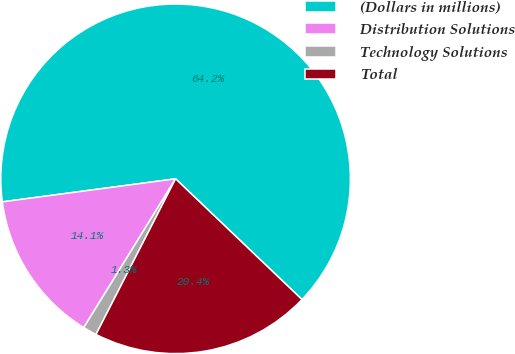Convert chart. <chart><loc_0><loc_0><loc_500><loc_500><pie_chart><fcel>(Dollars in millions)<fcel>Distribution Solutions<fcel>Technology Solutions<fcel>Total<nl><fcel>64.24%<fcel>14.09%<fcel>1.28%<fcel>20.39%<nl></chart> 